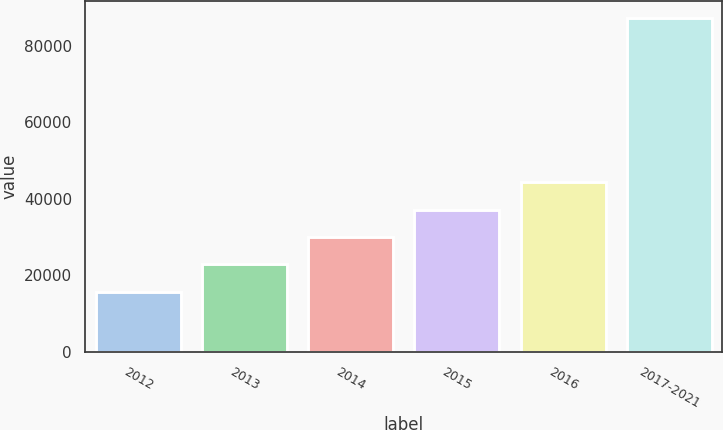<chart> <loc_0><loc_0><loc_500><loc_500><bar_chart><fcel>2012<fcel>2013<fcel>2014<fcel>2015<fcel>2016<fcel>2017-2021<nl><fcel>15725<fcel>22879.2<fcel>30033.4<fcel>37187.6<fcel>44341.8<fcel>87267<nl></chart> 